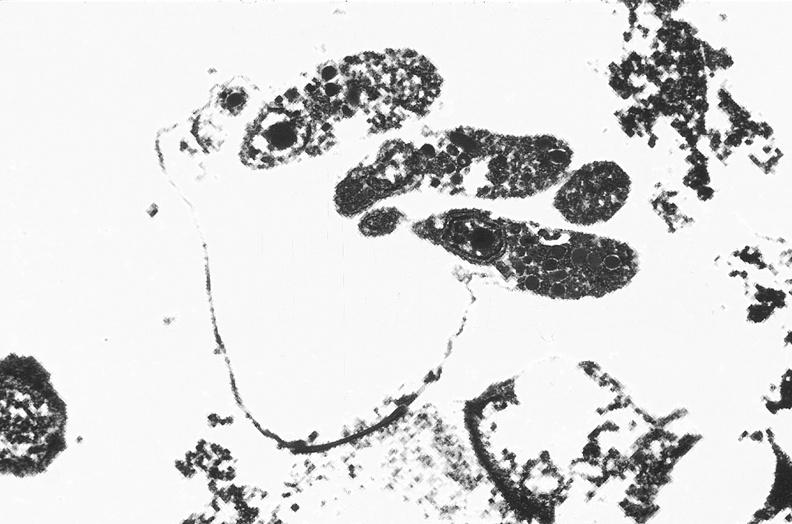what is present?
Answer the question using a single word or phrase. Gastrointestinal 